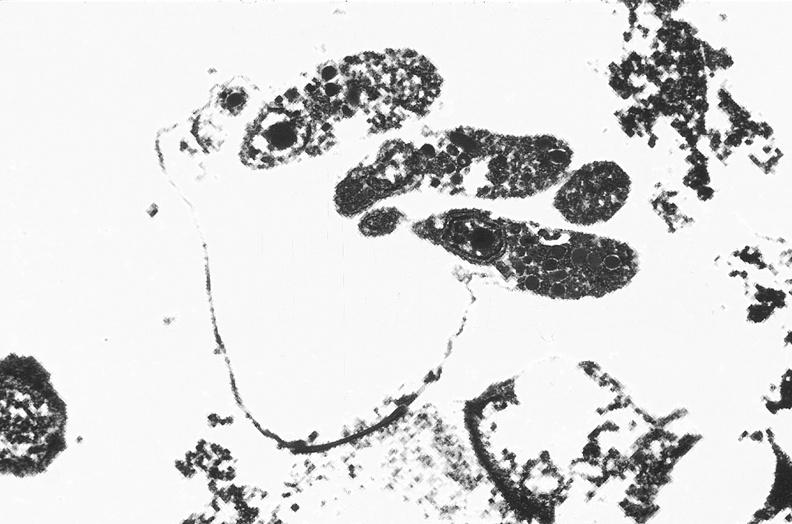what is present?
Answer the question using a single word or phrase. Gastrointestinal 